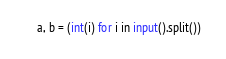Convert code to text. <code><loc_0><loc_0><loc_500><loc_500><_Python_>a, b = (int(i) for i in input().split())  </code> 